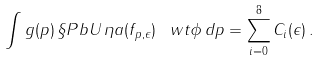<formula> <loc_0><loc_0><loc_500><loc_500>\int g ( p ) \, \S P b { U \, \eta } { a ( f _ { p , \epsilon } ) \, \ w t { \phi } } \, d p = \sum _ { i = 0 } ^ { 8 } C _ { i } ( \epsilon ) \, .</formula> 